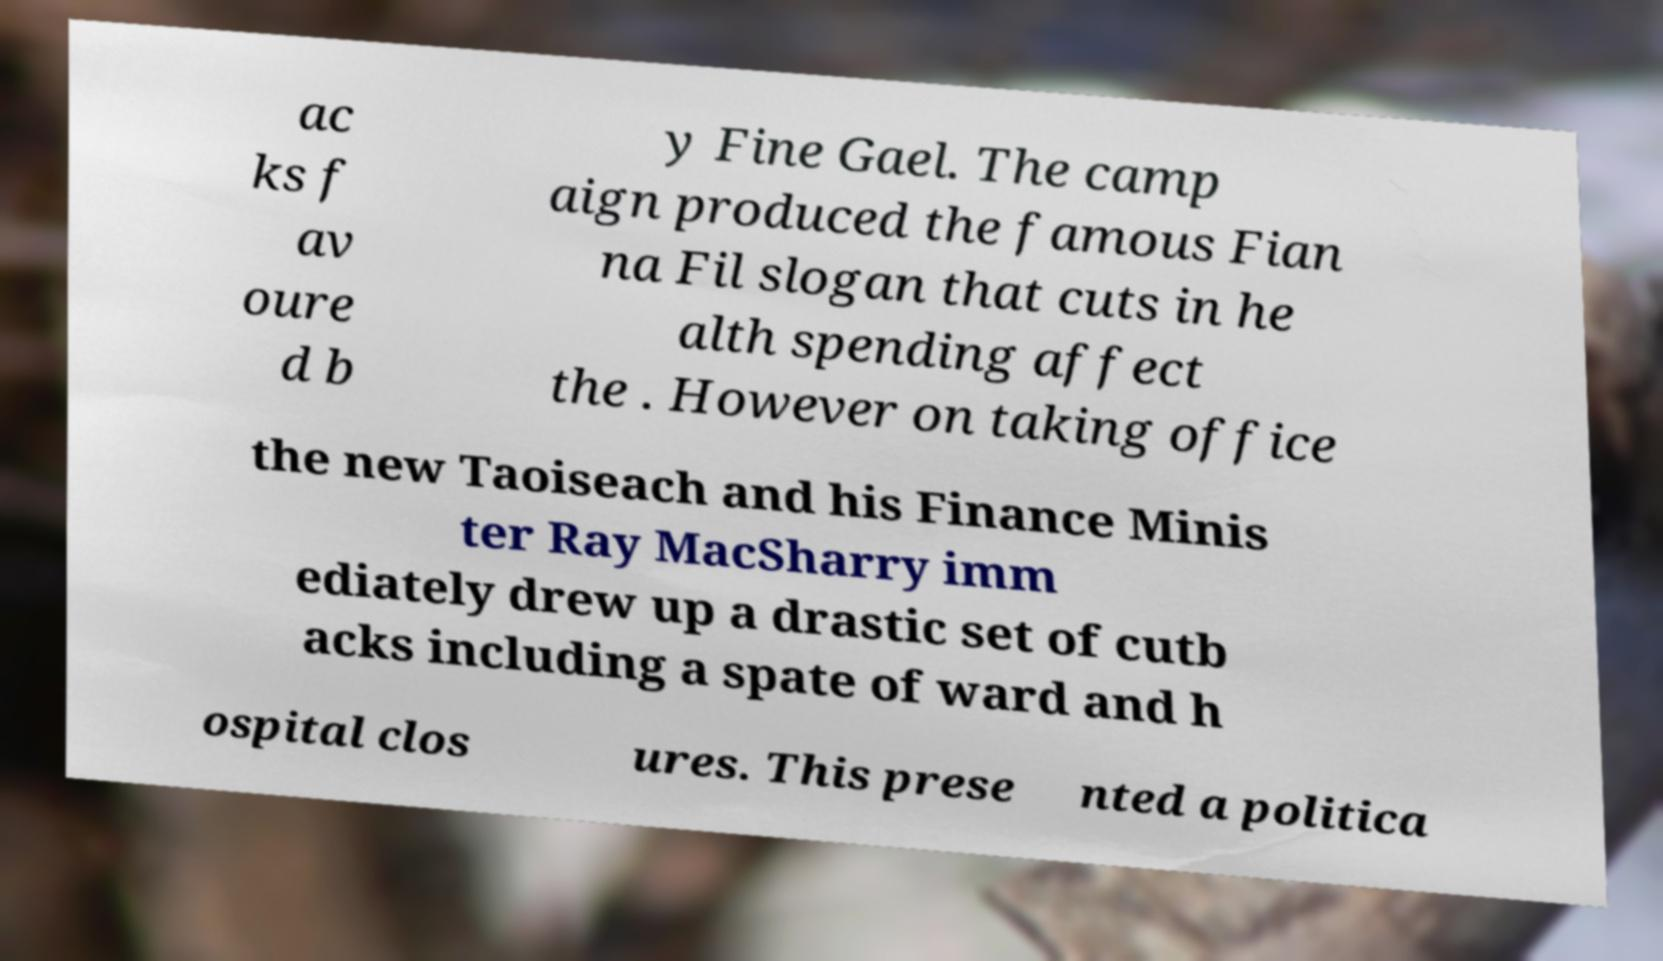Could you extract and type out the text from this image? ac ks f av oure d b y Fine Gael. The camp aign produced the famous Fian na Fil slogan that cuts in he alth spending affect the . However on taking office the new Taoiseach and his Finance Minis ter Ray MacSharry imm ediately drew up a drastic set of cutb acks including a spate of ward and h ospital clos ures. This prese nted a politica 